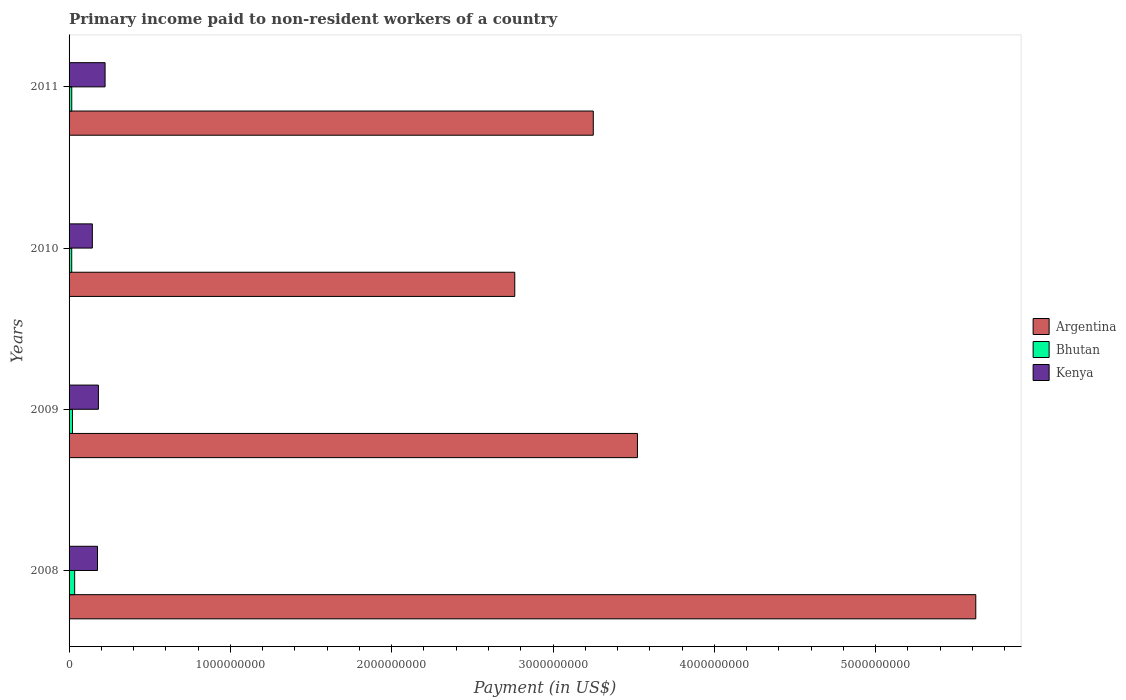How many different coloured bars are there?
Give a very brief answer. 3. How many groups of bars are there?
Your answer should be very brief. 4. What is the label of the 1st group of bars from the top?
Make the answer very short. 2011. What is the amount paid to workers in Bhutan in 2008?
Give a very brief answer. 3.47e+07. Across all years, what is the maximum amount paid to workers in Bhutan?
Your response must be concise. 3.47e+07. Across all years, what is the minimum amount paid to workers in Bhutan?
Ensure brevity in your answer.  1.64e+07. What is the total amount paid to workers in Kenya in the graph?
Offer a very short reply. 7.26e+08. What is the difference between the amount paid to workers in Bhutan in 2009 and that in 2011?
Offer a very short reply. 4.43e+06. What is the difference between the amount paid to workers in Kenya in 2009 and the amount paid to workers in Argentina in 2008?
Ensure brevity in your answer.  -5.44e+09. What is the average amount paid to workers in Kenya per year?
Provide a short and direct response. 1.81e+08. In the year 2008, what is the difference between the amount paid to workers in Argentina and amount paid to workers in Kenya?
Ensure brevity in your answer.  5.44e+09. In how many years, is the amount paid to workers in Kenya greater than 4000000000 US$?
Ensure brevity in your answer.  0. What is the ratio of the amount paid to workers in Kenya in 2010 to that in 2011?
Provide a succinct answer. 0.65. Is the amount paid to workers in Argentina in 2008 less than that in 2009?
Your answer should be compact. No. Is the difference between the amount paid to workers in Argentina in 2008 and 2011 greater than the difference between the amount paid to workers in Kenya in 2008 and 2011?
Provide a succinct answer. Yes. What is the difference between the highest and the second highest amount paid to workers in Kenya?
Ensure brevity in your answer.  4.14e+07. What is the difference between the highest and the lowest amount paid to workers in Argentina?
Offer a terse response. 2.86e+09. In how many years, is the amount paid to workers in Kenya greater than the average amount paid to workers in Kenya taken over all years?
Offer a very short reply. 2. What does the 1st bar from the bottom in 2010 represents?
Your answer should be very brief. Argentina. How many bars are there?
Provide a short and direct response. 12. How many years are there in the graph?
Your answer should be very brief. 4. Does the graph contain any zero values?
Provide a short and direct response. No. Does the graph contain grids?
Your response must be concise. No. Where does the legend appear in the graph?
Give a very brief answer. Center right. What is the title of the graph?
Provide a short and direct response. Primary income paid to non-resident workers of a country. Does "Libya" appear as one of the legend labels in the graph?
Offer a very short reply. No. What is the label or title of the X-axis?
Offer a terse response. Payment (in US$). What is the label or title of the Y-axis?
Make the answer very short. Years. What is the Payment (in US$) of Argentina in 2008?
Keep it short and to the point. 5.62e+09. What is the Payment (in US$) in Bhutan in 2008?
Ensure brevity in your answer.  3.47e+07. What is the Payment (in US$) of Kenya in 2008?
Provide a short and direct response. 1.76e+08. What is the Payment (in US$) in Argentina in 2009?
Provide a succinct answer. 3.52e+09. What is the Payment (in US$) of Bhutan in 2009?
Offer a very short reply. 2.11e+07. What is the Payment (in US$) of Kenya in 2009?
Make the answer very short. 1.82e+08. What is the Payment (in US$) in Argentina in 2010?
Ensure brevity in your answer.  2.76e+09. What is the Payment (in US$) in Bhutan in 2010?
Keep it short and to the point. 1.64e+07. What is the Payment (in US$) in Kenya in 2010?
Keep it short and to the point. 1.44e+08. What is the Payment (in US$) of Argentina in 2011?
Keep it short and to the point. 3.25e+09. What is the Payment (in US$) in Bhutan in 2011?
Make the answer very short. 1.66e+07. What is the Payment (in US$) in Kenya in 2011?
Keep it short and to the point. 2.23e+08. Across all years, what is the maximum Payment (in US$) of Argentina?
Provide a short and direct response. 5.62e+09. Across all years, what is the maximum Payment (in US$) of Bhutan?
Provide a short and direct response. 3.47e+07. Across all years, what is the maximum Payment (in US$) in Kenya?
Your answer should be very brief. 2.23e+08. Across all years, what is the minimum Payment (in US$) in Argentina?
Your answer should be compact. 2.76e+09. Across all years, what is the minimum Payment (in US$) in Bhutan?
Provide a succinct answer. 1.64e+07. Across all years, what is the minimum Payment (in US$) of Kenya?
Your answer should be very brief. 1.44e+08. What is the total Payment (in US$) in Argentina in the graph?
Your response must be concise. 1.52e+1. What is the total Payment (in US$) of Bhutan in the graph?
Your answer should be compact. 8.88e+07. What is the total Payment (in US$) in Kenya in the graph?
Offer a terse response. 7.26e+08. What is the difference between the Payment (in US$) in Argentina in 2008 and that in 2009?
Offer a terse response. 2.10e+09. What is the difference between the Payment (in US$) of Bhutan in 2008 and that in 2009?
Your response must be concise. 1.36e+07. What is the difference between the Payment (in US$) of Kenya in 2008 and that in 2009?
Make the answer very short. -5.64e+06. What is the difference between the Payment (in US$) in Argentina in 2008 and that in 2010?
Offer a very short reply. 2.86e+09. What is the difference between the Payment (in US$) in Bhutan in 2008 and that in 2010?
Your answer should be compact. 1.83e+07. What is the difference between the Payment (in US$) in Kenya in 2008 and that in 2010?
Keep it short and to the point. 3.20e+07. What is the difference between the Payment (in US$) of Argentina in 2008 and that in 2011?
Provide a short and direct response. 2.37e+09. What is the difference between the Payment (in US$) of Bhutan in 2008 and that in 2011?
Keep it short and to the point. 1.80e+07. What is the difference between the Payment (in US$) of Kenya in 2008 and that in 2011?
Your answer should be compact. -4.70e+07. What is the difference between the Payment (in US$) in Argentina in 2009 and that in 2010?
Your answer should be compact. 7.60e+08. What is the difference between the Payment (in US$) of Bhutan in 2009 and that in 2010?
Provide a short and direct response. 4.68e+06. What is the difference between the Payment (in US$) in Kenya in 2009 and that in 2010?
Keep it short and to the point. 3.76e+07. What is the difference between the Payment (in US$) of Argentina in 2009 and that in 2011?
Provide a succinct answer. 2.74e+08. What is the difference between the Payment (in US$) in Bhutan in 2009 and that in 2011?
Your answer should be compact. 4.43e+06. What is the difference between the Payment (in US$) in Kenya in 2009 and that in 2011?
Your response must be concise. -4.14e+07. What is the difference between the Payment (in US$) of Argentina in 2010 and that in 2011?
Your answer should be very brief. -4.87e+08. What is the difference between the Payment (in US$) in Bhutan in 2010 and that in 2011?
Your answer should be very brief. -2.57e+05. What is the difference between the Payment (in US$) in Kenya in 2010 and that in 2011?
Your answer should be compact. -7.90e+07. What is the difference between the Payment (in US$) in Argentina in 2008 and the Payment (in US$) in Bhutan in 2009?
Give a very brief answer. 5.60e+09. What is the difference between the Payment (in US$) of Argentina in 2008 and the Payment (in US$) of Kenya in 2009?
Keep it short and to the point. 5.44e+09. What is the difference between the Payment (in US$) in Bhutan in 2008 and the Payment (in US$) in Kenya in 2009?
Provide a short and direct response. -1.47e+08. What is the difference between the Payment (in US$) in Argentina in 2008 and the Payment (in US$) in Bhutan in 2010?
Keep it short and to the point. 5.60e+09. What is the difference between the Payment (in US$) of Argentina in 2008 and the Payment (in US$) of Kenya in 2010?
Provide a succinct answer. 5.48e+09. What is the difference between the Payment (in US$) in Bhutan in 2008 and the Payment (in US$) in Kenya in 2010?
Provide a succinct answer. -1.10e+08. What is the difference between the Payment (in US$) of Argentina in 2008 and the Payment (in US$) of Bhutan in 2011?
Keep it short and to the point. 5.60e+09. What is the difference between the Payment (in US$) of Argentina in 2008 and the Payment (in US$) of Kenya in 2011?
Your answer should be very brief. 5.40e+09. What is the difference between the Payment (in US$) of Bhutan in 2008 and the Payment (in US$) of Kenya in 2011?
Offer a terse response. -1.89e+08. What is the difference between the Payment (in US$) of Argentina in 2009 and the Payment (in US$) of Bhutan in 2010?
Provide a succinct answer. 3.51e+09. What is the difference between the Payment (in US$) of Argentina in 2009 and the Payment (in US$) of Kenya in 2010?
Give a very brief answer. 3.38e+09. What is the difference between the Payment (in US$) of Bhutan in 2009 and the Payment (in US$) of Kenya in 2010?
Your answer should be compact. -1.23e+08. What is the difference between the Payment (in US$) of Argentina in 2009 and the Payment (in US$) of Bhutan in 2011?
Keep it short and to the point. 3.51e+09. What is the difference between the Payment (in US$) in Argentina in 2009 and the Payment (in US$) in Kenya in 2011?
Provide a succinct answer. 3.30e+09. What is the difference between the Payment (in US$) of Bhutan in 2009 and the Payment (in US$) of Kenya in 2011?
Make the answer very short. -2.02e+08. What is the difference between the Payment (in US$) of Argentina in 2010 and the Payment (in US$) of Bhutan in 2011?
Provide a succinct answer. 2.75e+09. What is the difference between the Payment (in US$) in Argentina in 2010 and the Payment (in US$) in Kenya in 2011?
Offer a very short reply. 2.54e+09. What is the difference between the Payment (in US$) in Bhutan in 2010 and the Payment (in US$) in Kenya in 2011?
Offer a very short reply. -2.07e+08. What is the average Payment (in US$) in Argentina per year?
Your response must be concise. 3.79e+09. What is the average Payment (in US$) in Bhutan per year?
Make the answer very short. 2.22e+07. What is the average Payment (in US$) of Kenya per year?
Give a very brief answer. 1.81e+08. In the year 2008, what is the difference between the Payment (in US$) of Argentina and Payment (in US$) of Bhutan?
Keep it short and to the point. 5.59e+09. In the year 2008, what is the difference between the Payment (in US$) of Argentina and Payment (in US$) of Kenya?
Your response must be concise. 5.44e+09. In the year 2008, what is the difference between the Payment (in US$) in Bhutan and Payment (in US$) in Kenya?
Your answer should be compact. -1.42e+08. In the year 2009, what is the difference between the Payment (in US$) in Argentina and Payment (in US$) in Bhutan?
Provide a succinct answer. 3.50e+09. In the year 2009, what is the difference between the Payment (in US$) in Argentina and Payment (in US$) in Kenya?
Your answer should be compact. 3.34e+09. In the year 2009, what is the difference between the Payment (in US$) in Bhutan and Payment (in US$) in Kenya?
Your answer should be compact. -1.61e+08. In the year 2010, what is the difference between the Payment (in US$) in Argentina and Payment (in US$) in Bhutan?
Make the answer very short. 2.75e+09. In the year 2010, what is the difference between the Payment (in US$) in Argentina and Payment (in US$) in Kenya?
Make the answer very short. 2.62e+09. In the year 2010, what is the difference between the Payment (in US$) of Bhutan and Payment (in US$) of Kenya?
Offer a very short reply. -1.28e+08. In the year 2011, what is the difference between the Payment (in US$) of Argentina and Payment (in US$) of Bhutan?
Ensure brevity in your answer.  3.23e+09. In the year 2011, what is the difference between the Payment (in US$) of Argentina and Payment (in US$) of Kenya?
Your answer should be very brief. 3.03e+09. In the year 2011, what is the difference between the Payment (in US$) of Bhutan and Payment (in US$) of Kenya?
Keep it short and to the point. -2.07e+08. What is the ratio of the Payment (in US$) in Argentina in 2008 to that in 2009?
Give a very brief answer. 1.6. What is the ratio of the Payment (in US$) of Bhutan in 2008 to that in 2009?
Provide a succinct answer. 1.65. What is the ratio of the Payment (in US$) of Argentina in 2008 to that in 2010?
Provide a succinct answer. 2.03. What is the ratio of the Payment (in US$) of Bhutan in 2008 to that in 2010?
Offer a terse response. 2.12. What is the ratio of the Payment (in US$) in Kenya in 2008 to that in 2010?
Provide a succinct answer. 1.22. What is the ratio of the Payment (in US$) in Argentina in 2008 to that in 2011?
Make the answer very short. 1.73. What is the ratio of the Payment (in US$) in Bhutan in 2008 to that in 2011?
Offer a terse response. 2.08. What is the ratio of the Payment (in US$) in Kenya in 2008 to that in 2011?
Your answer should be very brief. 0.79. What is the ratio of the Payment (in US$) in Argentina in 2009 to that in 2010?
Make the answer very short. 1.28. What is the ratio of the Payment (in US$) in Kenya in 2009 to that in 2010?
Offer a terse response. 1.26. What is the ratio of the Payment (in US$) in Argentina in 2009 to that in 2011?
Provide a short and direct response. 1.08. What is the ratio of the Payment (in US$) of Bhutan in 2009 to that in 2011?
Provide a short and direct response. 1.27. What is the ratio of the Payment (in US$) of Kenya in 2009 to that in 2011?
Make the answer very short. 0.81. What is the ratio of the Payment (in US$) in Argentina in 2010 to that in 2011?
Provide a succinct answer. 0.85. What is the ratio of the Payment (in US$) in Bhutan in 2010 to that in 2011?
Keep it short and to the point. 0.98. What is the ratio of the Payment (in US$) in Kenya in 2010 to that in 2011?
Your answer should be very brief. 0.65. What is the difference between the highest and the second highest Payment (in US$) of Argentina?
Your response must be concise. 2.10e+09. What is the difference between the highest and the second highest Payment (in US$) of Bhutan?
Provide a succinct answer. 1.36e+07. What is the difference between the highest and the second highest Payment (in US$) in Kenya?
Keep it short and to the point. 4.14e+07. What is the difference between the highest and the lowest Payment (in US$) of Argentina?
Your answer should be very brief. 2.86e+09. What is the difference between the highest and the lowest Payment (in US$) in Bhutan?
Ensure brevity in your answer.  1.83e+07. What is the difference between the highest and the lowest Payment (in US$) of Kenya?
Make the answer very short. 7.90e+07. 